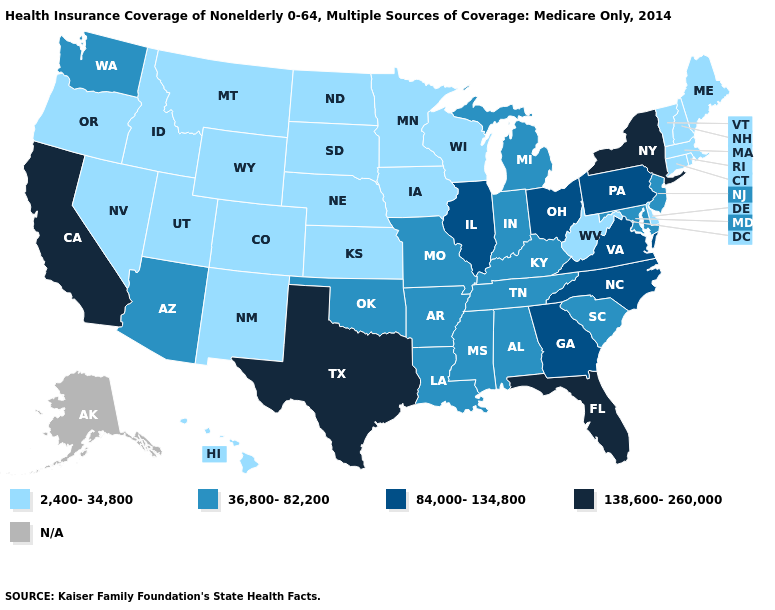What is the value of Delaware?
Give a very brief answer. 2,400-34,800. Does Massachusetts have the highest value in the USA?
Quick response, please. No. Which states have the lowest value in the West?
Write a very short answer. Colorado, Hawaii, Idaho, Montana, Nevada, New Mexico, Oregon, Utah, Wyoming. Name the states that have a value in the range 138,600-260,000?
Quick response, please. California, Florida, New York, Texas. Name the states that have a value in the range 84,000-134,800?
Give a very brief answer. Georgia, Illinois, North Carolina, Ohio, Pennsylvania, Virginia. Name the states that have a value in the range N/A?
Short answer required. Alaska. What is the highest value in the West ?
Quick response, please. 138,600-260,000. Among the states that border Vermont , which have the highest value?
Be succinct. New York. What is the highest value in the Northeast ?
Answer briefly. 138,600-260,000. What is the highest value in the USA?
Keep it brief. 138,600-260,000. Among the states that border Utah , which have the highest value?
Be succinct. Arizona. What is the value of Georgia?
Answer briefly. 84,000-134,800. What is the value of Georgia?
Concise answer only. 84,000-134,800. 